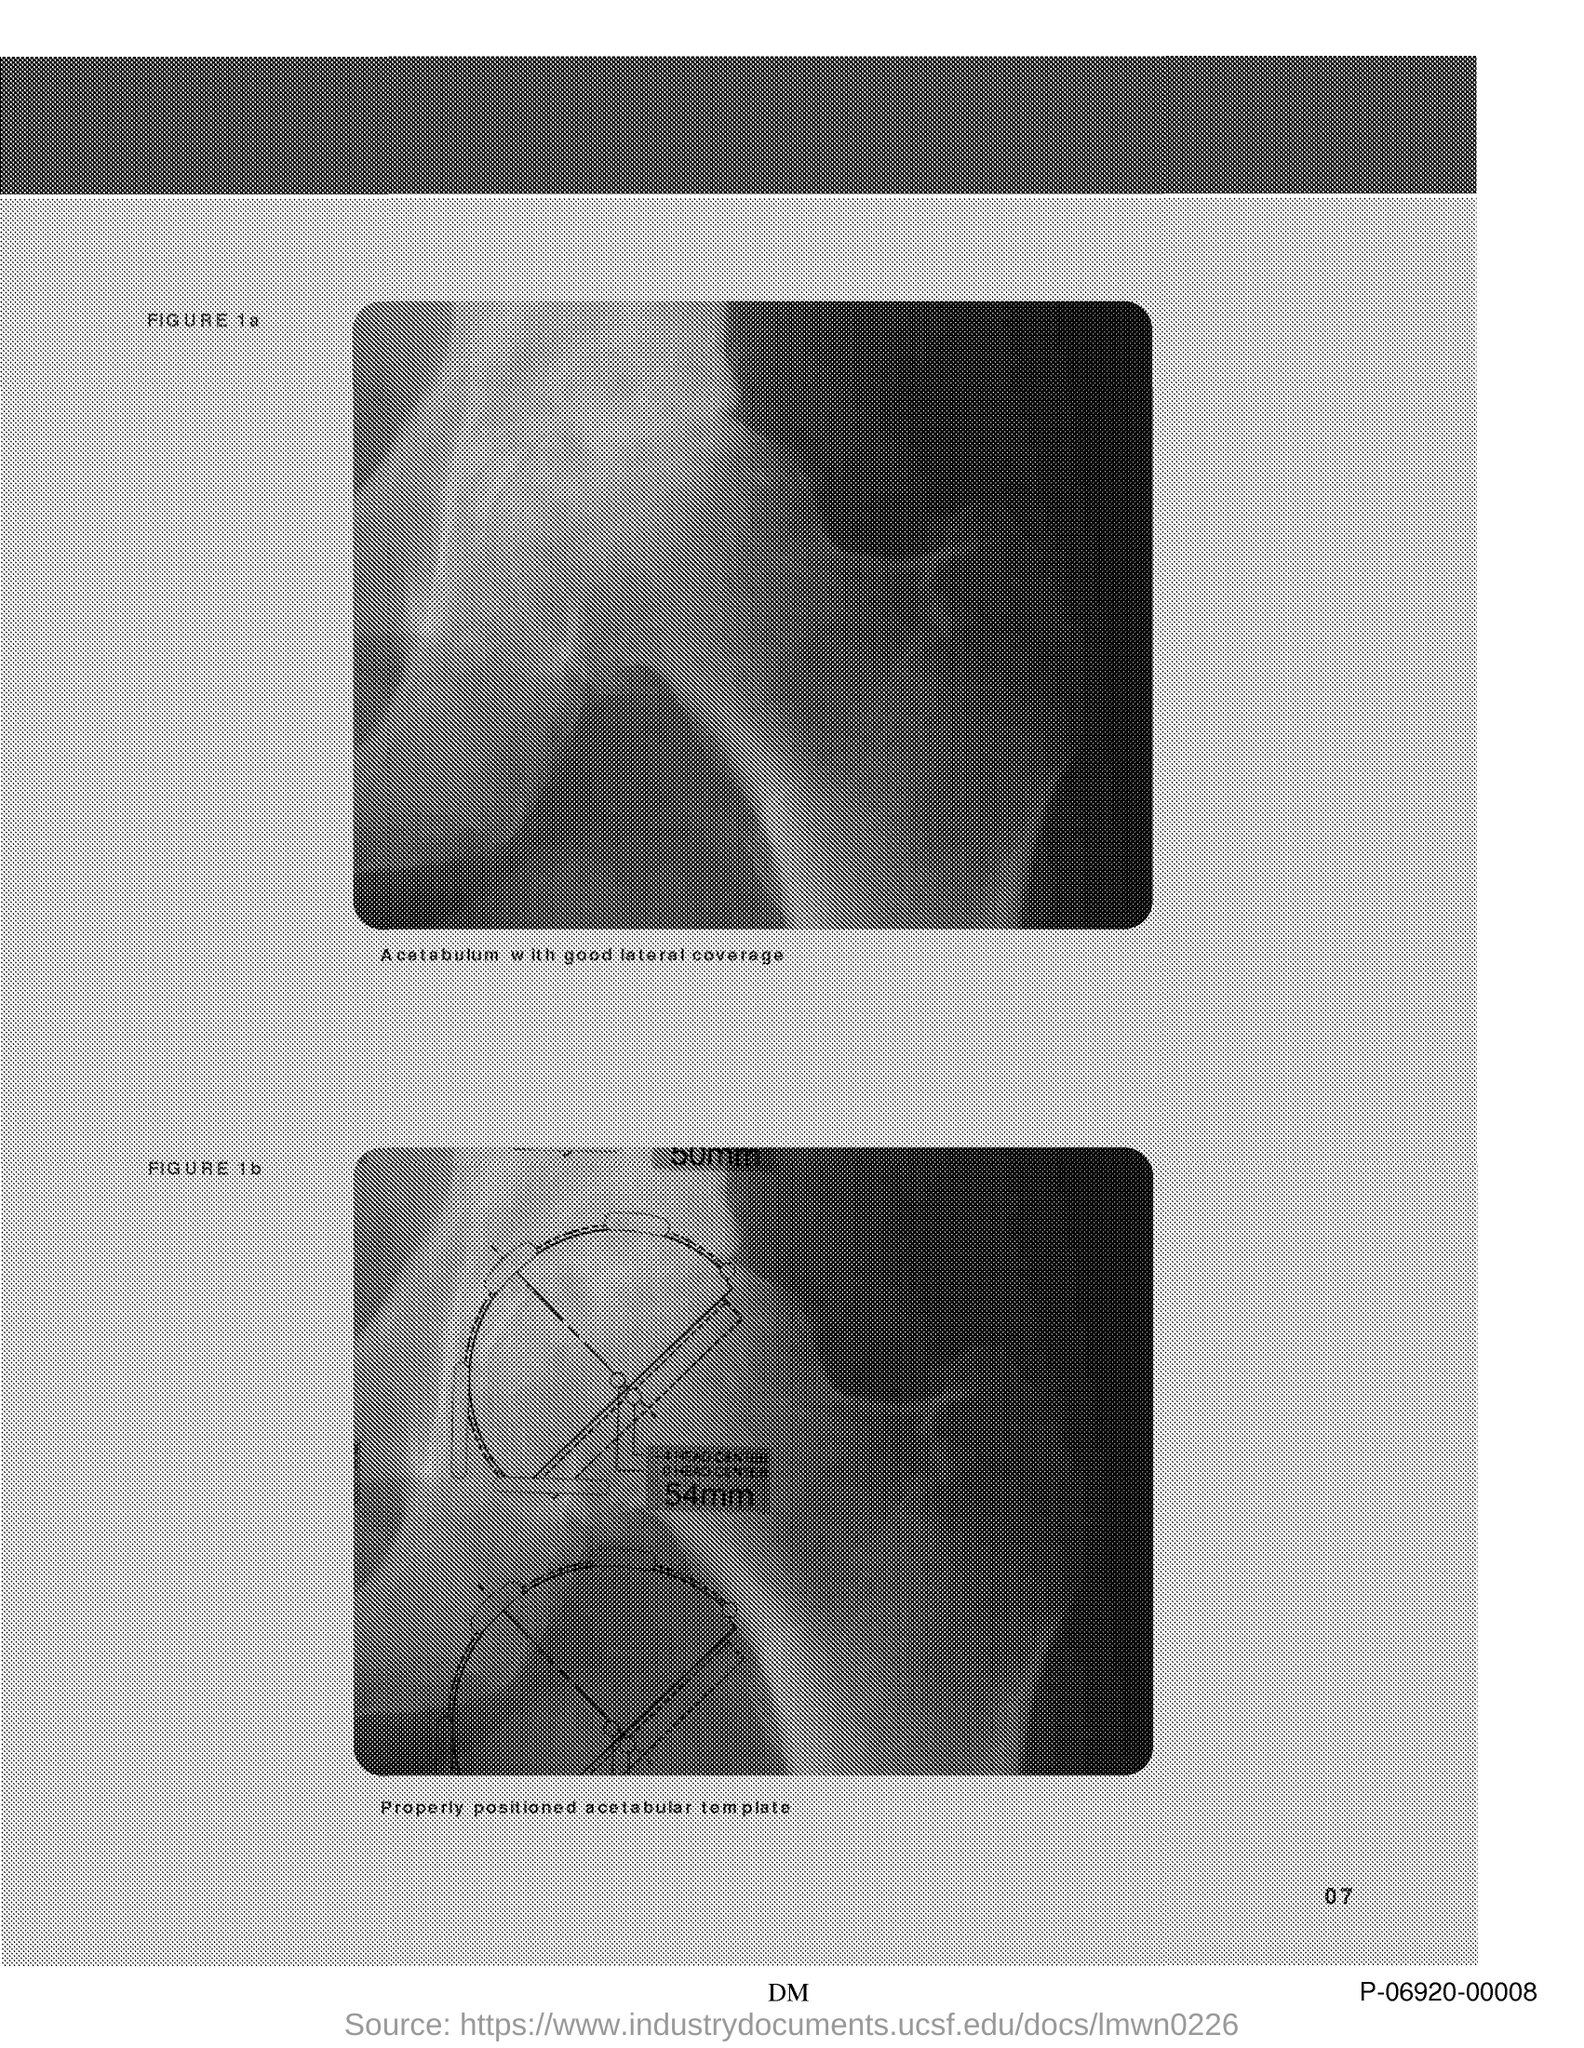What is the text written below the first figure?
Offer a terse response. Acetabulum with good lateral coverage. 